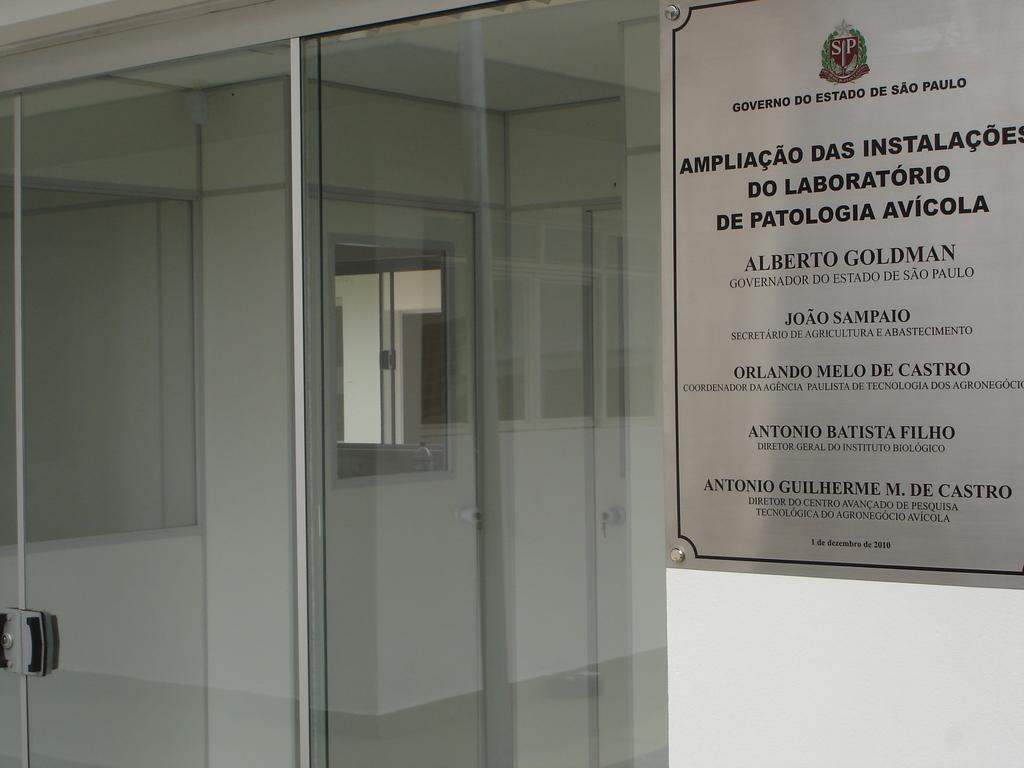<image>
Render a clear and concise summary of the photo. A sign mentions several people, including Alberto GOldman and Joao Sampaio. 